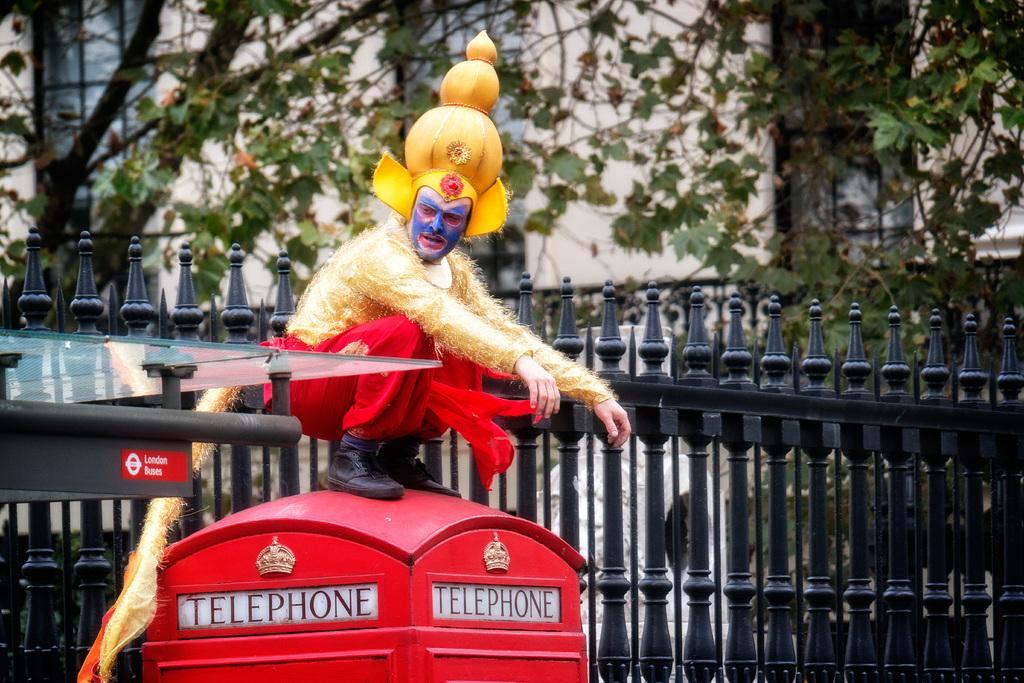In one or two sentences, can you explain what this image depicts? In this image I can see a red colour telephone booth and on the top of it I can see a man. I can see he is wearing a costume. On the left side of this image I can see a pole and a glass on it. In the background I can see Iron fencing, number of trees and a building. 